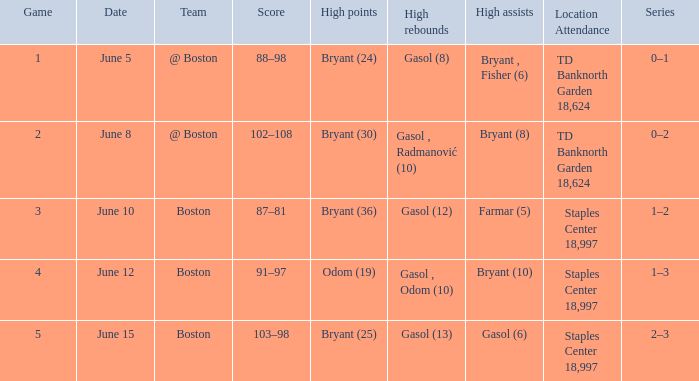Name the number of games on june 12 1.0. Parse the table in full. {'header': ['Game', 'Date', 'Team', 'Score', 'High points', 'High rebounds', 'High assists', 'Location Attendance', 'Series'], 'rows': [['1', 'June 5', '@ Boston', '88–98', 'Bryant (24)', 'Gasol (8)', 'Bryant , Fisher (6)', 'TD Banknorth Garden 18,624', '0–1'], ['2', 'June 8', '@ Boston', '102–108', 'Bryant (30)', 'Gasol , Radmanović (10)', 'Bryant (8)', 'TD Banknorth Garden 18,624', '0–2'], ['3', 'June 10', 'Boston', '87–81', 'Bryant (36)', 'Gasol (12)', 'Farmar (5)', 'Staples Center 18,997', '1–2'], ['4', 'June 12', 'Boston', '91–97', 'Odom (19)', 'Gasol , Odom (10)', 'Bryant (10)', 'Staples Center 18,997', '1–3'], ['5', 'June 15', 'Boston', '103–98', 'Bryant (25)', 'Gasol (13)', 'Gasol (6)', 'Staples Center 18,997', '2–3']]} 